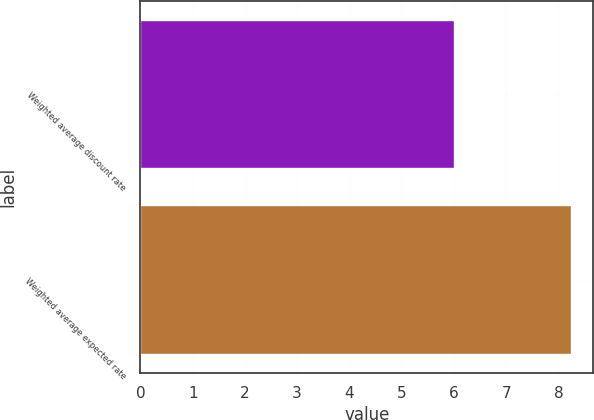Convert chart to OTSL. <chart><loc_0><loc_0><loc_500><loc_500><bar_chart><fcel>Weighted average discount rate<fcel>Weighted average expected rate<nl><fcel>6<fcel>8.25<nl></chart> 